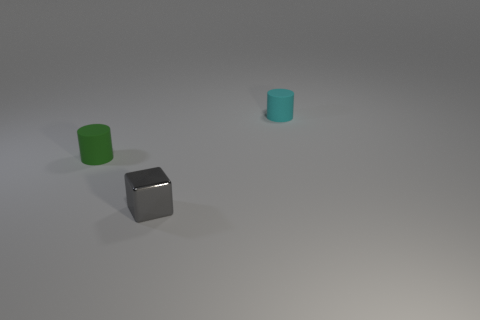Subtract all red cubes. Subtract all gray spheres. How many cubes are left? 1 Add 2 cyan cylinders. How many objects exist? 5 Subtract all cylinders. How many objects are left? 1 Subtract 0 red balls. How many objects are left? 3 Subtract all small green shiny balls. Subtract all green cylinders. How many objects are left? 2 Add 2 shiny things. How many shiny things are left? 3 Add 1 large red rubber cylinders. How many large red rubber cylinders exist? 1 